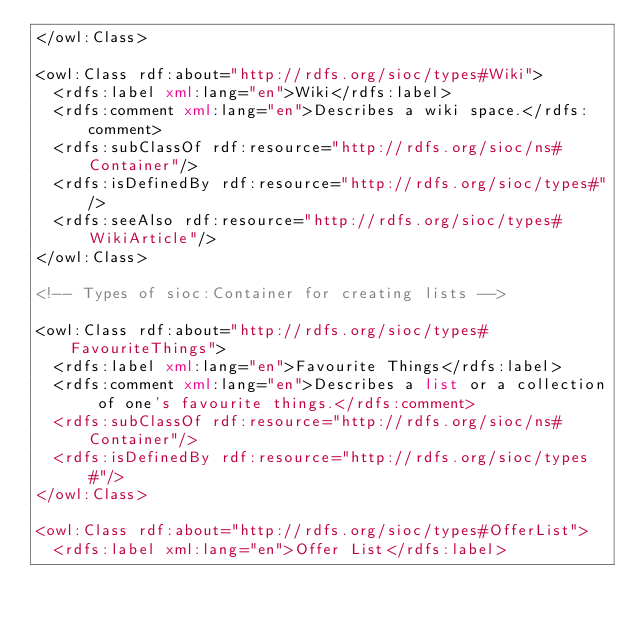Convert code to text. <code><loc_0><loc_0><loc_500><loc_500><_XML_></owl:Class>

<owl:Class rdf:about="http://rdfs.org/sioc/types#Wiki">
  <rdfs:label xml:lang="en">Wiki</rdfs:label>
  <rdfs:comment xml:lang="en">Describes a wiki space.</rdfs:comment>
  <rdfs:subClassOf rdf:resource="http://rdfs.org/sioc/ns#Container"/>
  <rdfs:isDefinedBy rdf:resource="http://rdfs.org/sioc/types#"/>
  <rdfs:seeAlso rdf:resource="http://rdfs.org/sioc/types#WikiArticle"/>  
</owl:Class>

<!-- Types of sioc:Container for creating lists -->

<owl:Class rdf:about="http://rdfs.org/sioc/types#FavouriteThings">
  <rdfs:label xml:lang="en">Favourite Things</rdfs:label>
  <rdfs:comment xml:lang="en">Describes a list or a collection of one's favourite things.</rdfs:comment>
  <rdfs:subClassOf rdf:resource="http://rdfs.org/sioc/ns#Container"/>
  <rdfs:isDefinedBy rdf:resource="http://rdfs.org/sioc/types#"/>
</owl:Class>

<owl:Class rdf:about="http://rdfs.org/sioc/types#OfferList">
  <rdfs:label xml:lang="en">Offer List</rdfs:label></code> 